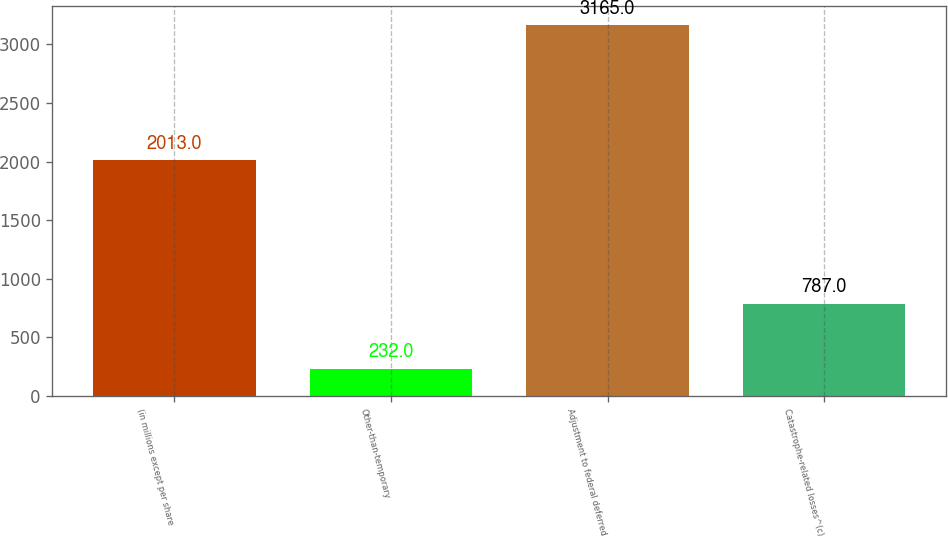Convert chart. <chart><loc_0><loc_0><loc_500><loc_500><bar_chart><fcel>(in millions except per share<fcel>Other-than-temporary<fcel>Adjustment to federal deferred<fcel>Catastrophe-related losses^(c)<nl><fcel>2013<fcel>232<fcel>3165<fcel>787<nl></chart> 